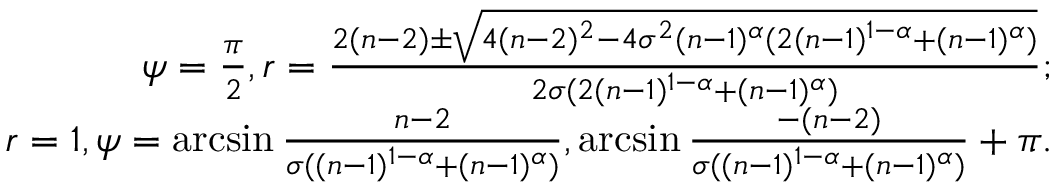<formula> <loc_0><loc_0><loc_500><loc_500>\begin{array} { r } { \psi = \frac { \pi } { 2 } , r = \frac { 2 ( n - 2 ) \pm \sqrt { 4 ( n - 2 ) ^ { 2 } - 4 \sigma ^ { 2 } ( n - 1 ) ^ { \alpha } ( 2 ( n - 1 ) ^ { 1 - \alpha } + ( n - 1 ) ^ { \alpha } ) } } { 2 \sigma ( 2 ( n - 1 ) ^ { 1 - \alpha } + ( n - 1 ) ^ { \alpha } ) } ; } \\ { r = 1 , \psi = \arcsin { \frac { n - 2 } { \sigma ( ( n - 1 ) ^ { 1 - \alpha } + ( n - 1 ) ^ { \alpha } ) } } , \arcsin { \frac { - ( n - 2 ) } { \sigma ( ( n - 1 ) ^ { 1 - \alpha } + ( n - 1 ) ^ { \alpha } ) } } + \pi . } \end{array}</formula> 